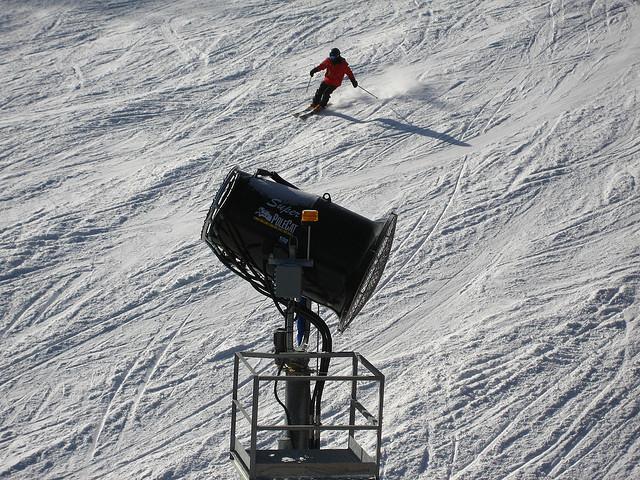What is the man doing?
Write a very short answer. Skiing. What is yellow in this pic?
Quick response, please. Light. What is white on the ground?
Give a very brief answer. Snow. 